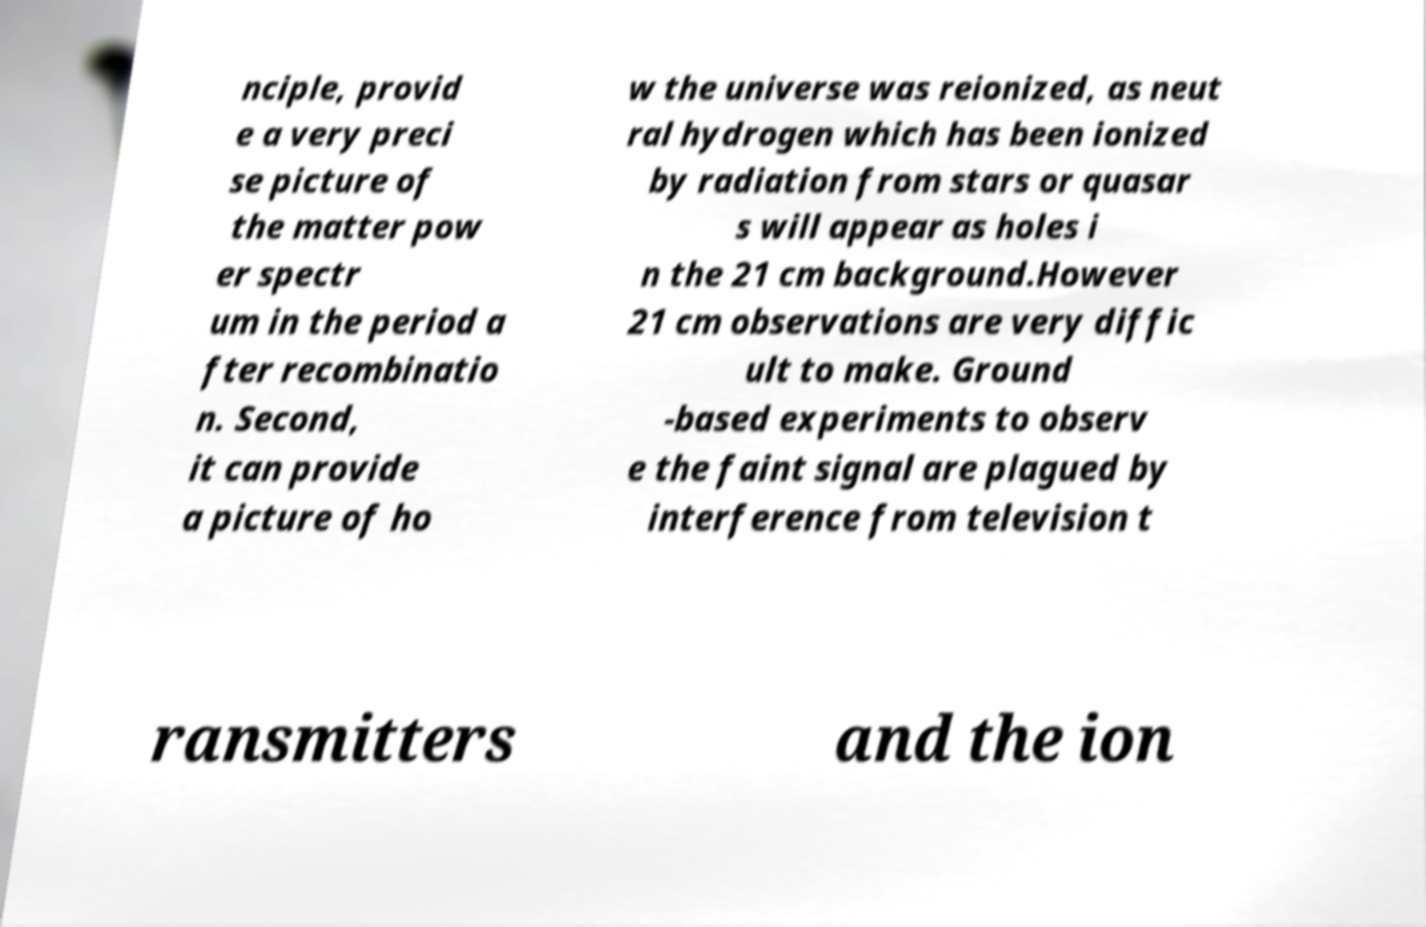Can you accurately transcribe the text from the provided image for me? nciple, provid e a very preci se picture of the matter pow er spectr um in the period a fter recombinatio n. Second, it can provide a picture of ho w the universe was reionized, as neut ral hydrogen which has been ionized by radiation from stars or quasar s will appear as holes i n the 21 cm background.However 21 cm observations are very diffic ult to make. Ground -based experiments to observ e the faint signal are plagued by interference from television t ransmitters and the ion 